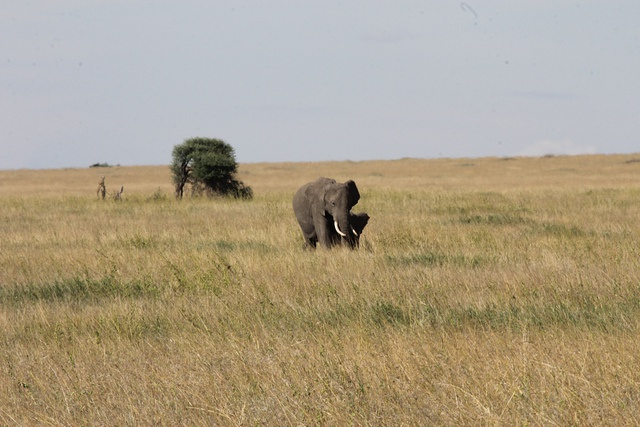Describe the objects in this image and their specific colors. I can see elephant in lightgray, gray, and black tones and elephant in lightgray, black, and gray tones in this image. 